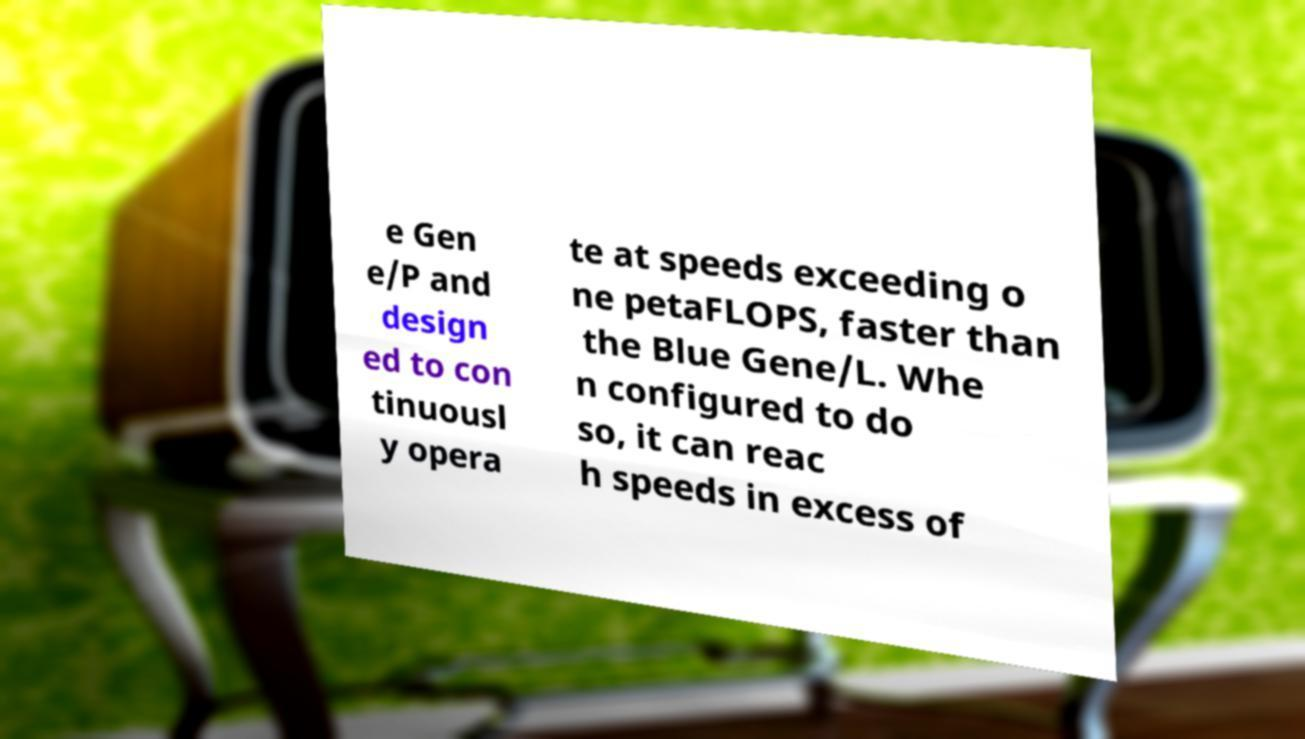Please read and relay the text visible in this image. What does it say? e Gen e/P and design ed to con tinuousl y opera te at speeds exceeding o ne petaFLOPS, faster than the Blue Gene/L. Whe n configured to do so, it can reac h speeds in excess of 